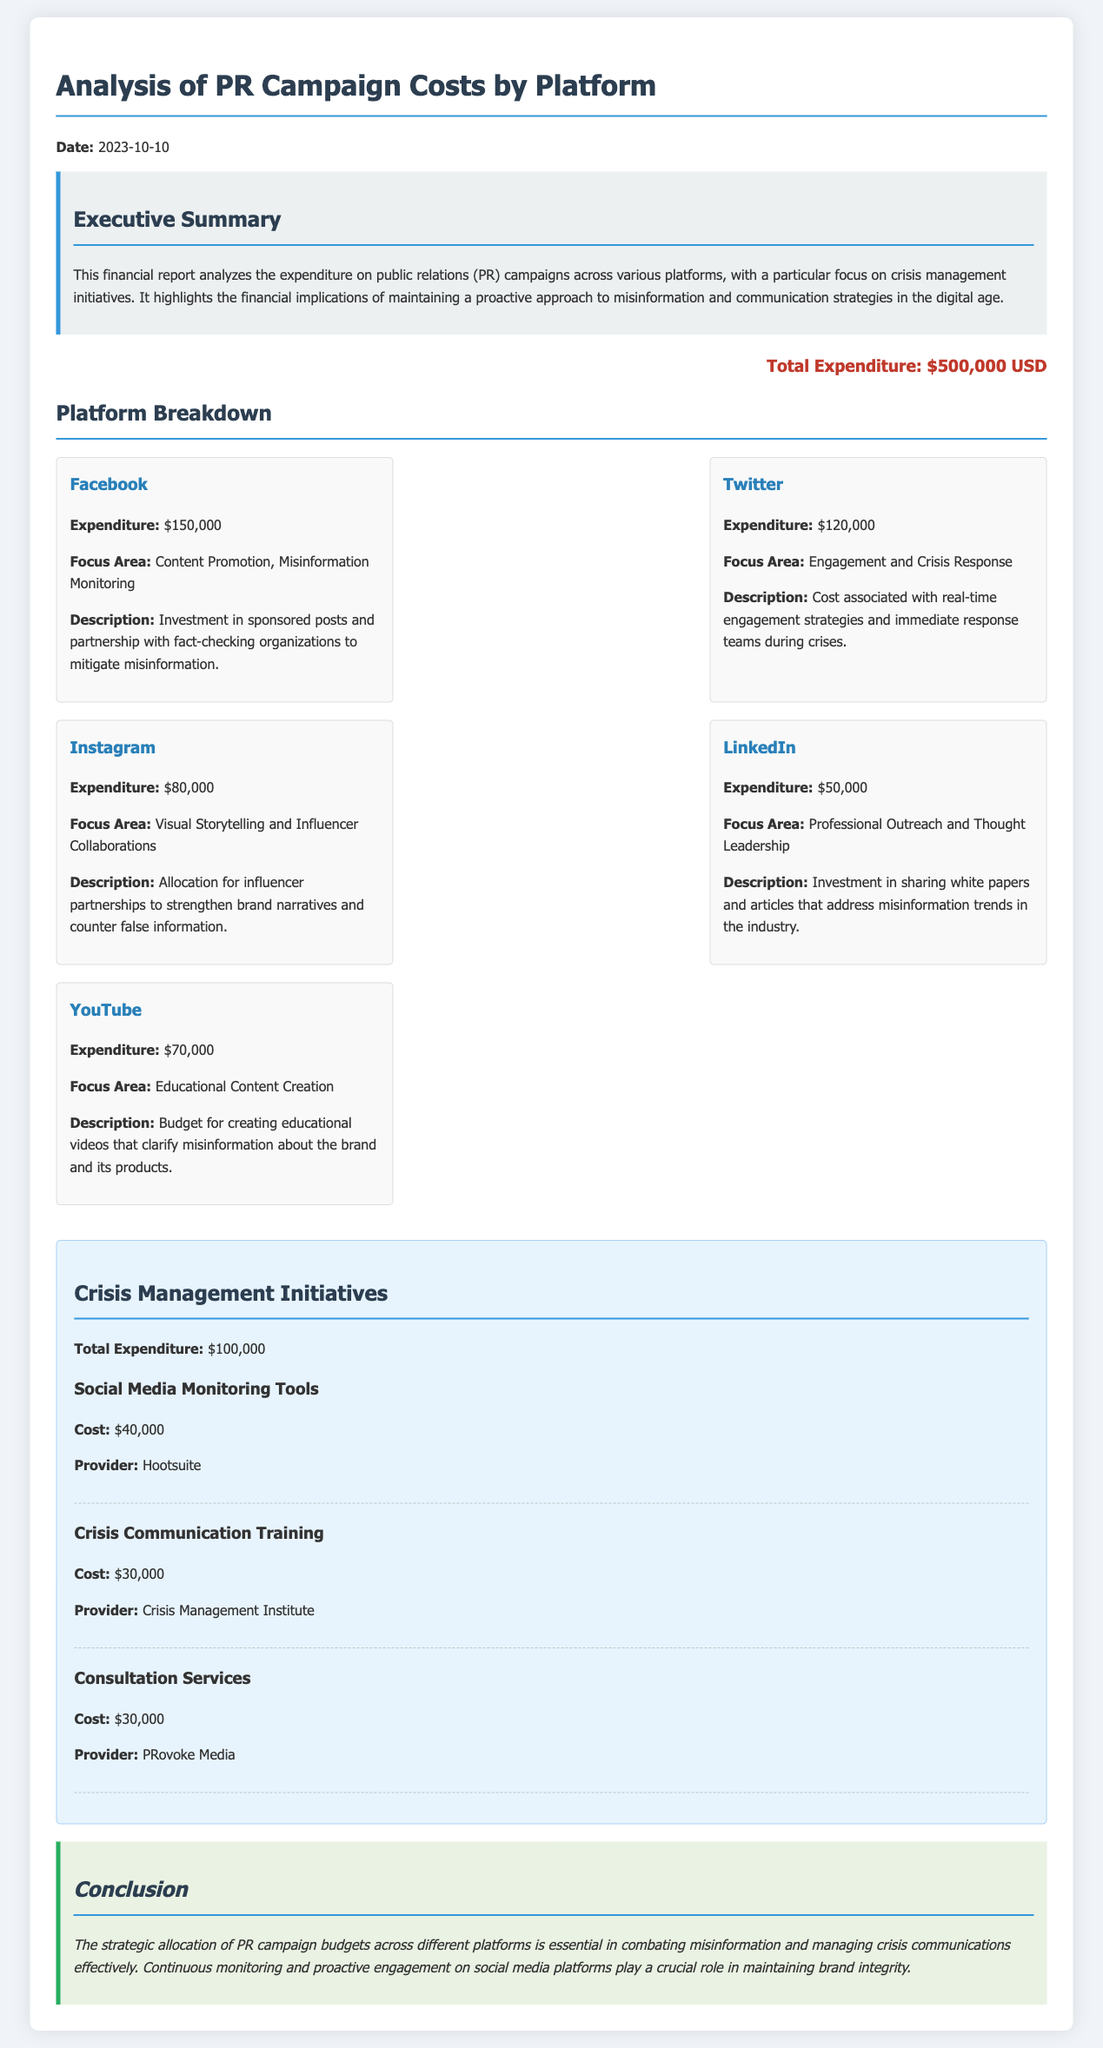What is the total expenditure on the PR campaign? The total expenditure is stated at the end of the document under the "Total Expenditure" section, which amounts to $500,000 USD.
Answer: $500,000 USD How much was spent on Facebook? The expenditure for Facebook is mentioned in the "Platform Breakdown" section, which lists it as $150,000.
Answer: $150,000 What platform had the least expenditure? The expenditure amounts for each platform are listed, and LinkedIn has the lowest expenditure of $50,000.
Answer: $50,000 What is the total expenditure on crisis management initiatives? The total expenditure for crisis management initiatives is provided specifically in the "Crisis Management Initiatives" section, tallying to $100,000.
Answer: $100,000 Which platform focuses on visual storytelling? The "Platform Breakdown" section indicates that Instagram emphasizes visual storytelling as its focus area.
Answer: Instagram What was the cost of social media monitoring tools? The cost is detailed in the "Crisis Management Initiatives" section, where it specifies $40,000 for social media monitoring tools.
Answer: $40,000 What organization provided crisis communication training? The provider for crisis communication training is listed under the "Crisis Management Initiatives" section as the Crisis Management Institute.
Answer: Crisis Management Institute Which platform has a focus on content promotion? The focus area for Facebook is identified as content promotion in the "Platform Breakdown" section.
Answer: Facebook What educational content is created for YouTube? The description mentions that the educational content aims to clarify misinformation about the brand and its products specifically for YouTube.
Answer: Educational videos 